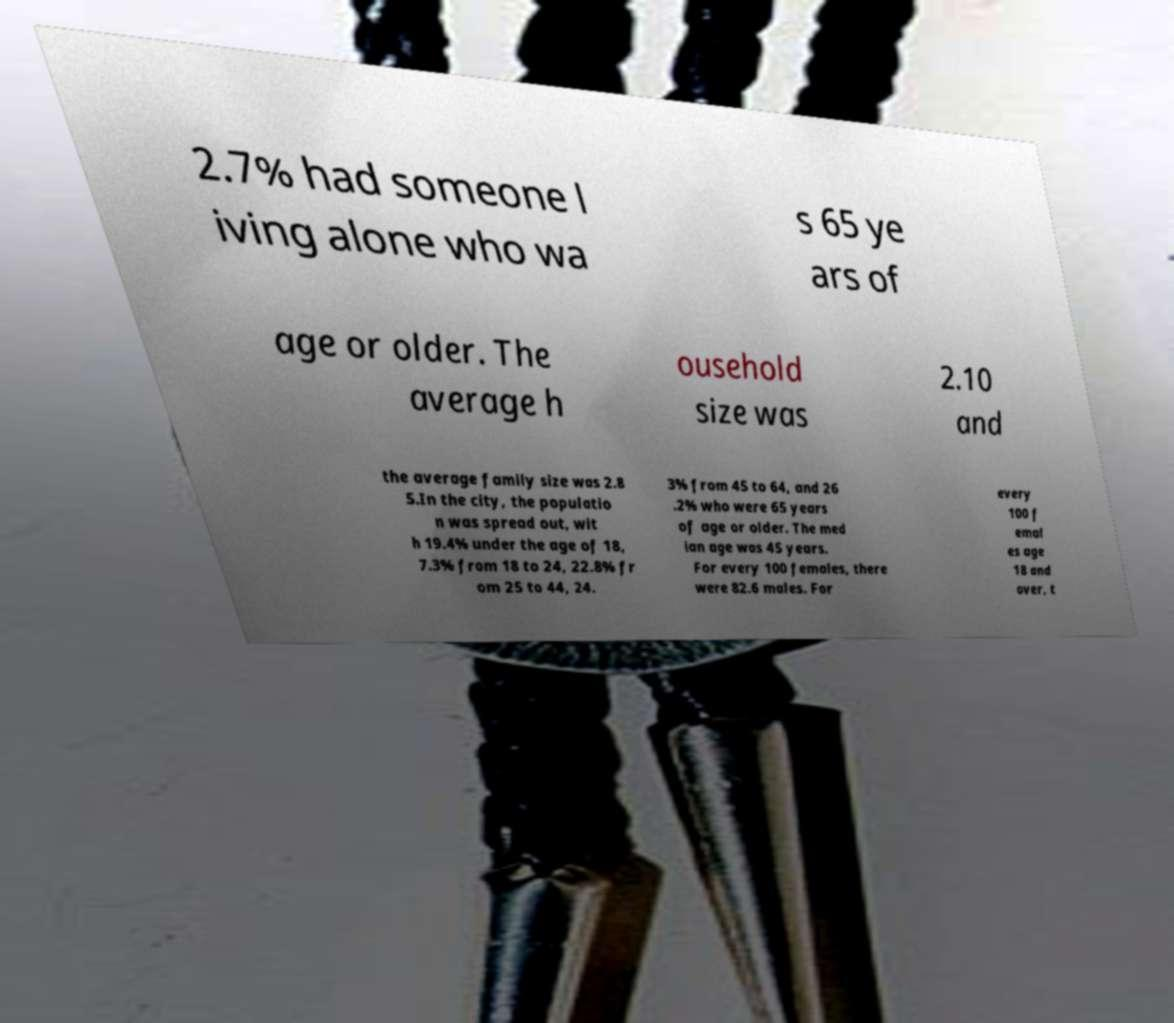For documentation purposes, I need the text within this image transcribed. Could you provide that? 2.7% had someone l iving alone who wa s 65 ye ars of age or older. The average h ousehold size was 2.10 and the average family size was 2.8 5.In the city, the populatio n was spread out, wit h 19.4% under the age of 18, 7.3% from 18 to 24, 22.8% fr om 25 to 44, 24. 3% from 45 to 64, and 26 .2% who were 65 years of age or older. The med ian age was 45 years. For every 100 females, there were 82.6 males. For every 100 f emal es age 18 and over, t 